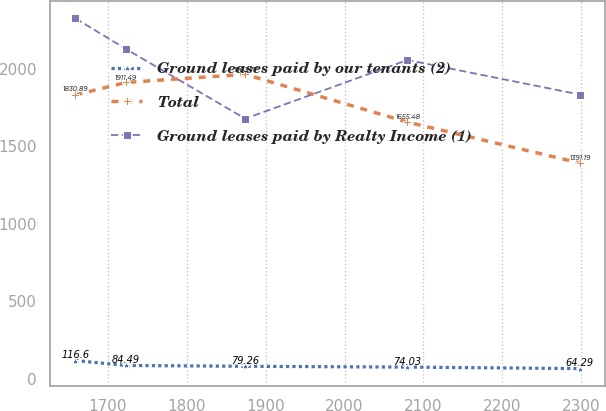<chart> <loc_0><loc_0><loc_500><loc_500><line_chart><ecel><fcel>Ground leases paid by our tenants (2)<fcel>Total<fcel>Ground leases paid by Realty Income (1)<nl><fcel>1658.89<fcel>116.6<fcel>1830.89<fcel>2325.32<nl><fcel>1722.85<fcel>84.49<fcel>1911.49<fcel>2127.91<nl><fcel>1874.17<fcel>79.26<fcel>1963.77<fcel>1677.94<nl><fcel>2079.83<fcel>74.03<fcel>1655.48<fcel>2056.5<nl><fcel>2298.48<fcel>64.29<fcel>1391.19<fcel>1833.31<nl></chart> 